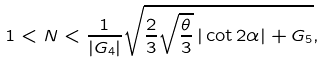<formula> <loc_0><loc_0><loc_500><loc_500>1 < N < \frac { 1 } { | G _ { 4 } | } \sqrt { \frac { 2 } { 3 } \sqrt { \frac { \theta } { 3 } } \, | \cot 2 \alpha | + G _ { 5 } } ,</formula> 